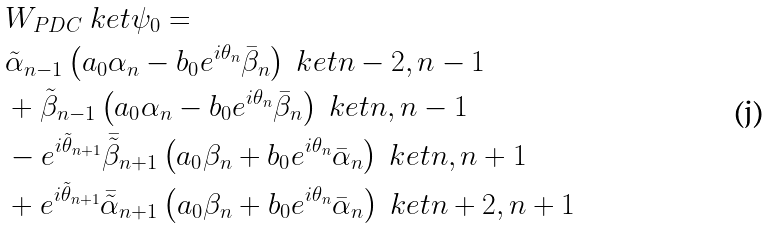<formula> <loc_0><loc_0><loc_500><loc_500>& W _ { P D C } \ k e t { \psi _ { 0 } } = \\ & \tilde { \alpha } _ { n - 1 } \left ( a _ { 0 } \alpha _ { n } - b _ { 0 } e ^ { i \theta _ { n } } \bar { \beta } _ { n } \right ) \ k e t { n - 2 , n - 1 } \\ & + \tilde { \beta } _ { n - 1 } \left ( a _ { 0 } \alpha _ { n } - b _ { 0 } e ^ { i \theta _ { n } } \bar { \beta } _ { n } \right ) \ k e t { n , n - 1 } \\ & - e ^ { i \tilde { \theta } _ { n + 1 } } \bar { \tilde { \beta } } _ { n + 1 } \left ( a _ { 0 } \beta _ { n } + b _ { 0 } e ^ { i \theta _ { n } } \bar { \alpha } _ { n } \right ) \ k e t { n , n + 1 } \\ & + e ^ { i \tilde { \theta } _ { n + 1 } } \bar { \tilde { \alpha } } _ { n + 1 } \left ( a _ { 0 } \beta _ { n } + b _ { 0 } e ^ { i \theta _ { n } } \bar { \alpha } _ { n } \right ) \ k e t { n + 2 , n + 1 }</formula> 